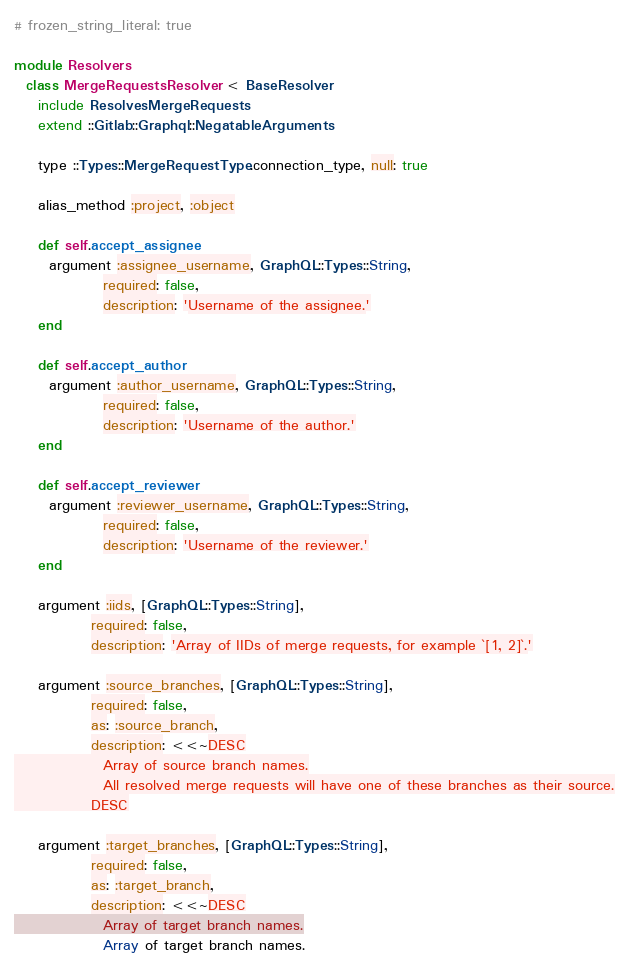Convert code to text. <code><loc_0><loc_0><loc_500><loc_500><_Ruby_># frozen_string_literal: true

module Resolvers
  class MergeRequestsResolver < BaseResolver
    include ResolvesMergeRequests
    extend ::Gitlab::Graphql::NegatableArguments

    type ::Types::MergeRequestType.connection_type, null: true

    alias_method :project, :object

    def self.accept_assignee
      argument :assignee_username, GraphQL::Types::String,
               required: false,
               description: 'Username of the assignee.'
    end

    def self.accept_author
      argument :author_username, GraphQL::Types::String,
               required: false,
               description: 'Username of the author.'
    end

    def self.accept_reviewer
      argument :reviewer_username, GraphQL::Types::String,
               required: false,
               description: 'Username of the reviewer.'
    end

    argument :iids, [GraphQL::Types::String],
             required: false,
             description: 'Array of IIDs of merge requests, for example `[1, 2]`.'

    argument :source_branches, [GraphQL::Types::String],
             required: false,
             as: :source_branch,
             description: <<~DESC
               Array of source branch names.
               All resolved merge requests will have one of these branches as their source.
             DESC

    argument :target_branches, [GraphQL::Types::String],
             required: false,
             as: :target_branch,
             description: <<~DESC
               Array of target branch names.</code> 